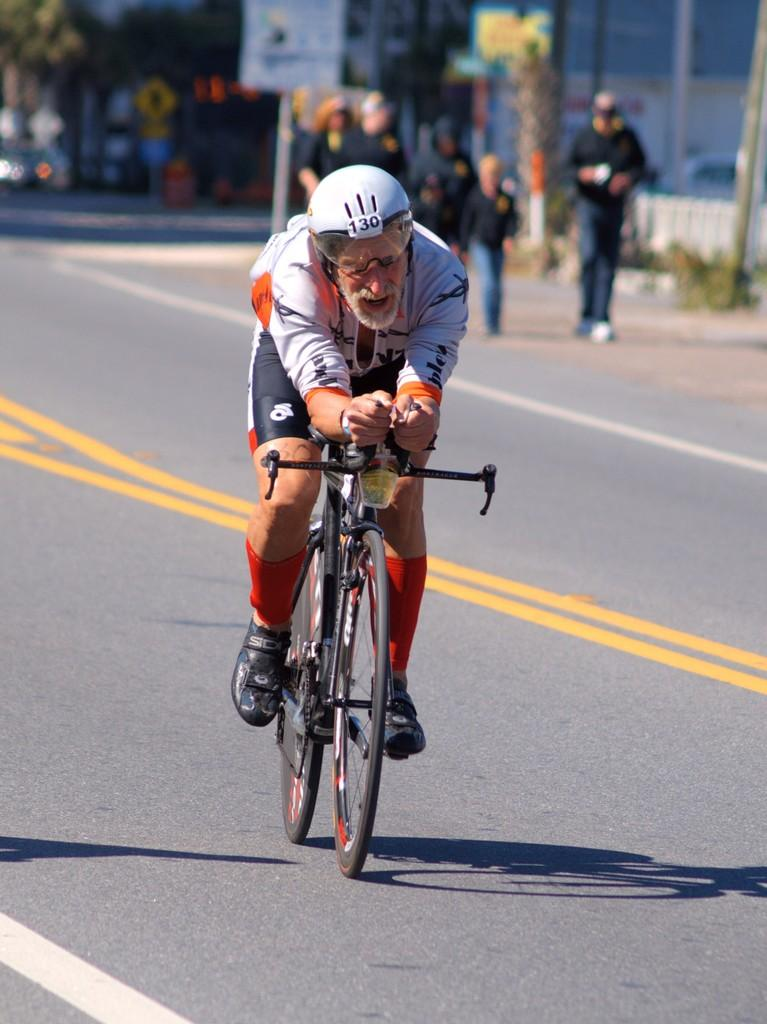Who is the main subject in the picture? There is an old man in the picture. What is the old man doing in the picture? The old man is riding a bicycle. What safety precaution is the old man taking while riding the bicycle? The old man is wearing a helmet. Where is the old man located in the picture? The old man is on the road. What can be seen in the background of the picture? There are people walking and trees in the background. What type of water can be seen flowing next to the old man while he is riding the bicycle? There is no water visible in the image; the old man is riding a bicycle on the road. 